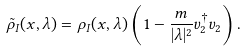Convert formula to latex. <formula><loc_0><loc_0><loc_500><loc_500>\tilde { \rho } _ { I } ( x , \lambda ) = \rho _ { I } ( x , \lambda ) \left ( 1 - \frac { m } { | \lambda | ^ { 2 } } v _ { 2 } ^ { \dagger } v _ { 2 } \right ) .</formula> 